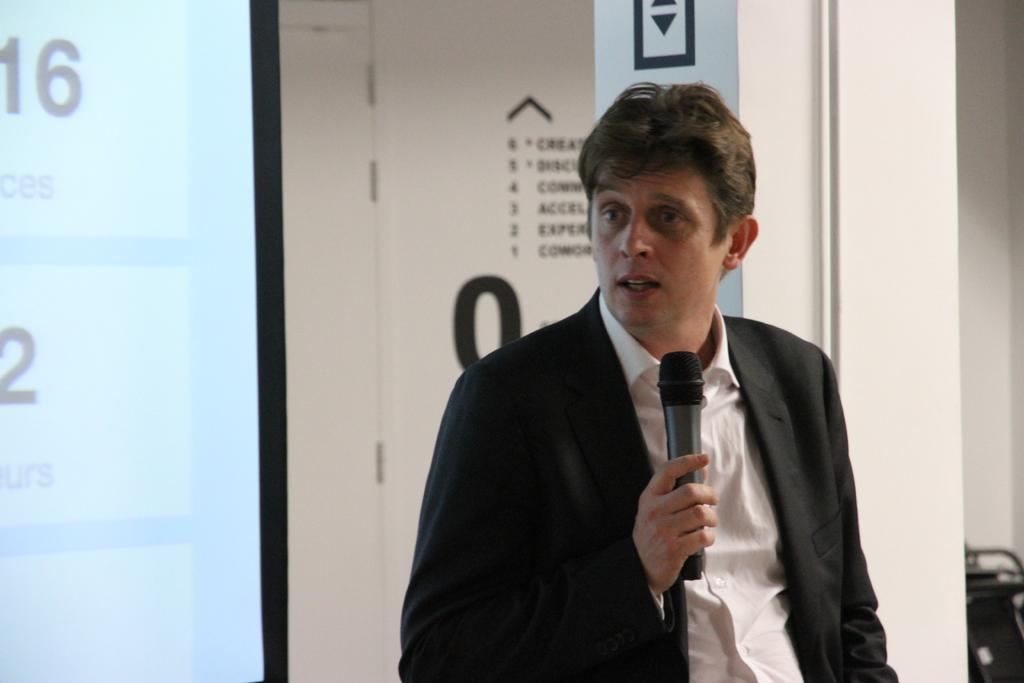In one or two sentences, can you explain what this image depicts? In this picture a guy who is wearing a black coat in his one of his hand , in the background there is a glass window. 